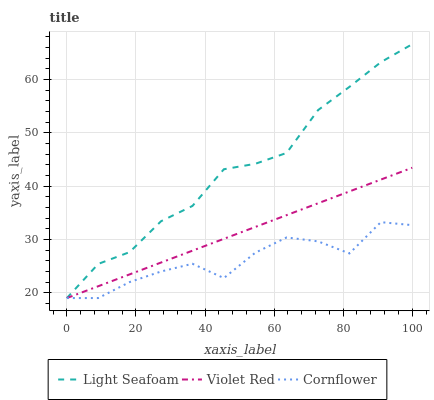Does Cornflower have the minimum area under the curve?
Answer yes or no. Yes. Does Light Seafoam have the maximum area under the curve?
Answer yes or no. Yes. Does Violet Red have the minimum area under the curve?
Answer yes or no. No. Does Violet Red have the maximum area under the curve?
Answer yes or no. No. Is Violet Red the smoothest?
Answer yes or no. Yes. Is Cornflower the roughest?
Answer yes or no. Yes. Is Light Seafoam the smoothest?
Answer yes or no. No. Is Light Seafoam the roughest?
Answer yes or no. No. Does Violet Red have the highest value?
Answer yes or no. No. 